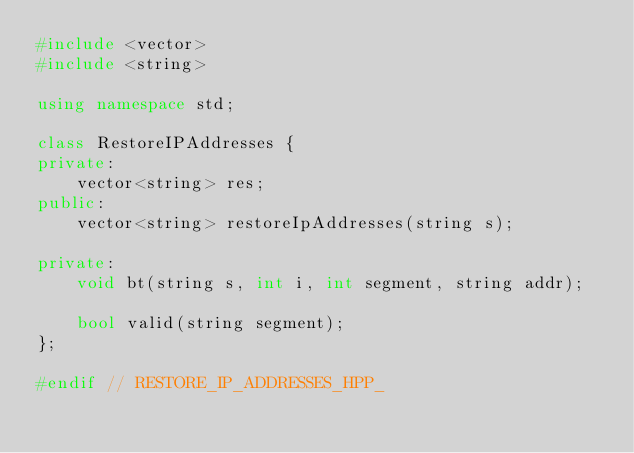Convert code to text. <code><loc_0><loc_0><loc_500><loc_500><_C++_>#include <vector>
#include <string>

using namespace std;

class RestoreIPAddresses {
private:
    vector<string> res;
public:
    vector<string> restoreIpAddresses(string s);

private:
    void bt(string s, int i, int segment, string addr);

    bool valid(string segment);
};

#endif // RESTORE_IP_ADDRESSES_HPP_
</code> 